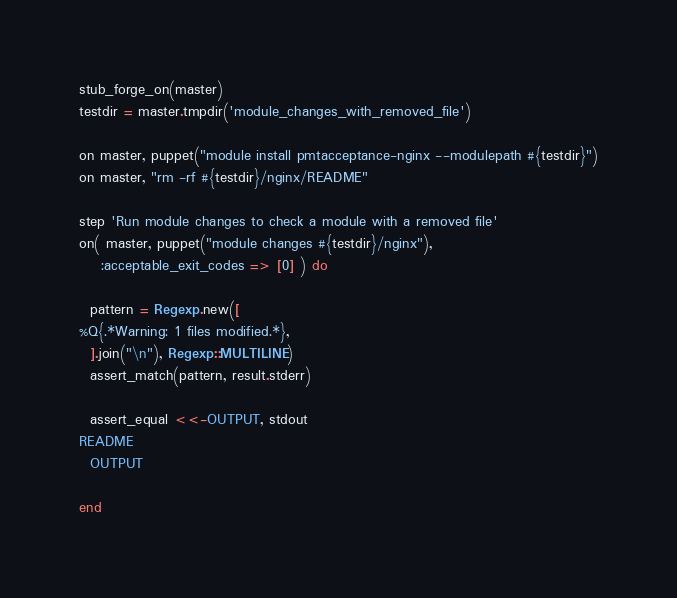<code> <loc_0><loc_0><loc_500><loc_500><_Ruby_>stub_forge_on(master)
testdir = master.tmpdir('module_changes_with_removed_file')

on master, puppet("module install pmtacceptance-nginx --modulepath #{testdir}")
on master, "rm -rf #{testdir}/nginx/README"

step 'Run module changes to check a module with a removed file'
on( master, puppet("module changes #{testdir}/nginx"),
    :acceptable_exit_codes => [0] ) do

  pattern = Regexp.new([
%Q{.*Warning: 1 files modified.*},
  ].join("\n"), Regexp::MULTILINE)
  assert_match(pattern, result.stderr)

  assert_equal <<-OUTPUT, stdout
README
  OUTPUT

end
</code> 